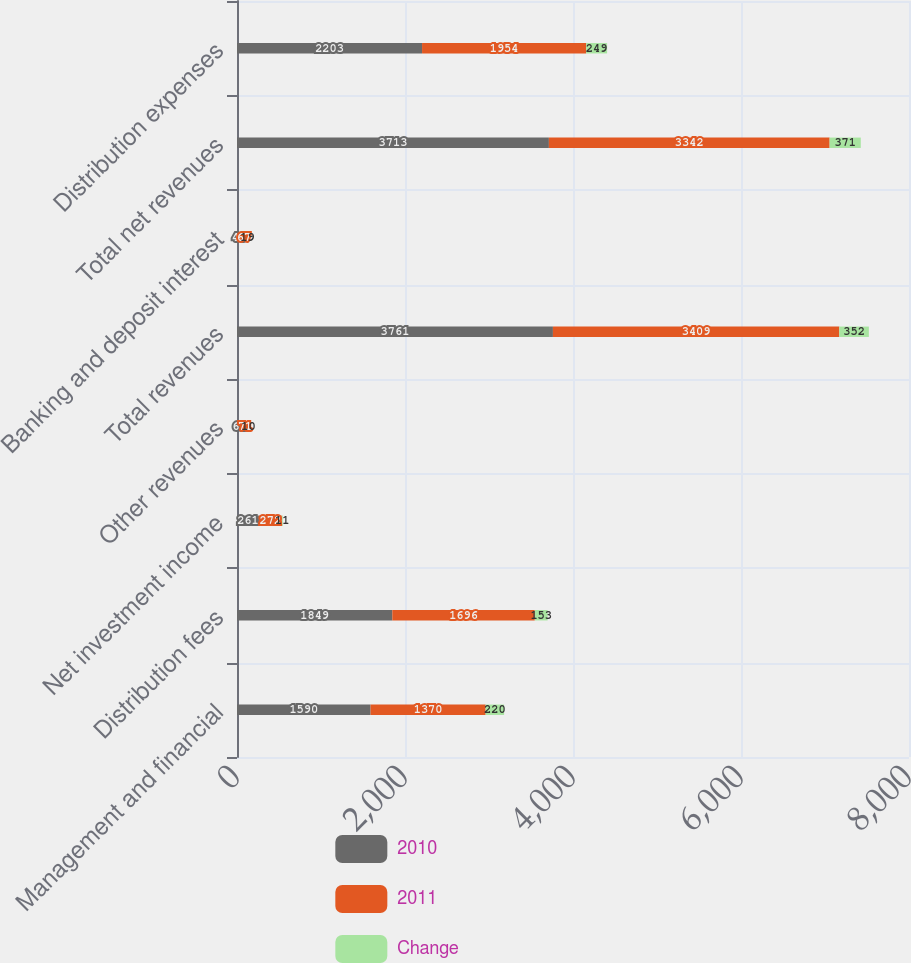<chart> <loc_0><loc_0><loc_500><loc_500><stacked_bar_chart><ecel><fcel>Management and financial<fcel>Distribution fees<fcel>Net investment income<fcel>Other revenues<fcel>Total revenues<fcel>Banking and deposit interest<fcel>Total net revenues<fcel>Distribution expenses<nl><fcel>2010<fcel>1590<fcel>1849<fcel>261<fcel>61<fcel>3761<fcel>48<fcel>3713<fcel>2203<nl><fcel>2011<fcel>1370<fcel>1696<fcel>272<fcel>71<fcel>3409<fcel>67<fcel>3342<fcel>1954<nl><fcel>Change<fcel>220<fcel>153<fcel>11<fcel>10<fcel>352<fcel>19<fcel>371<fcel>249<nl></chart> 